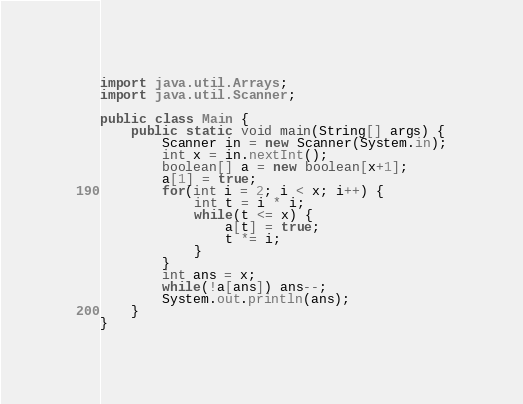Convert code to text. <code><loc_0><loc_0><loc_500><loc_500><_Java_>import java.util.Arrays;
import java.util.Scanner;

public class Main {
    public static void main(String[] args) {
        Scanner in = new Scanner(System.in);
        int x = in.nextInt();
        boolean[] a = new boolean[x+1];
        a[1] = true;
        for(int i = 2; i < x; i++) {
            int t = i * i;
            while(t <= x) {
                a[t] = true;
                t *= i;
            }
        }
        int ans = x;
        while(!a[ans]) ans--;
        System.out.println(ans);
    }
}</code> 